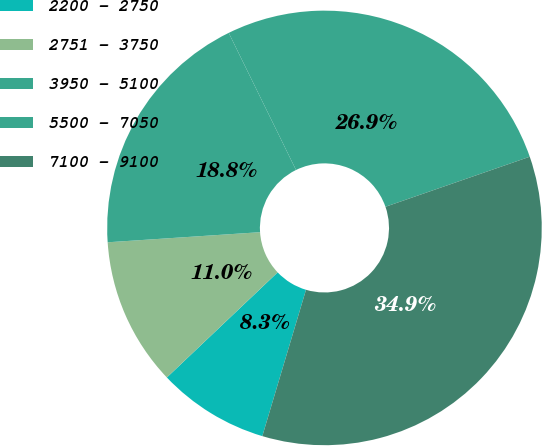Convert chart. <chart><loc_0><loc_0><loc_500><loc_500><pie_chart><fcel>2200 - 2750<fcel>2751 - 3750<fcel>3950 - 5100<fcel>5500 - 7050<fcel>7100 - 9100<nl><fcel>8.3%<fcel>11.03%<fcel>18.79%<fcel>26.95%<fcel>34.93%<nl></chart> 